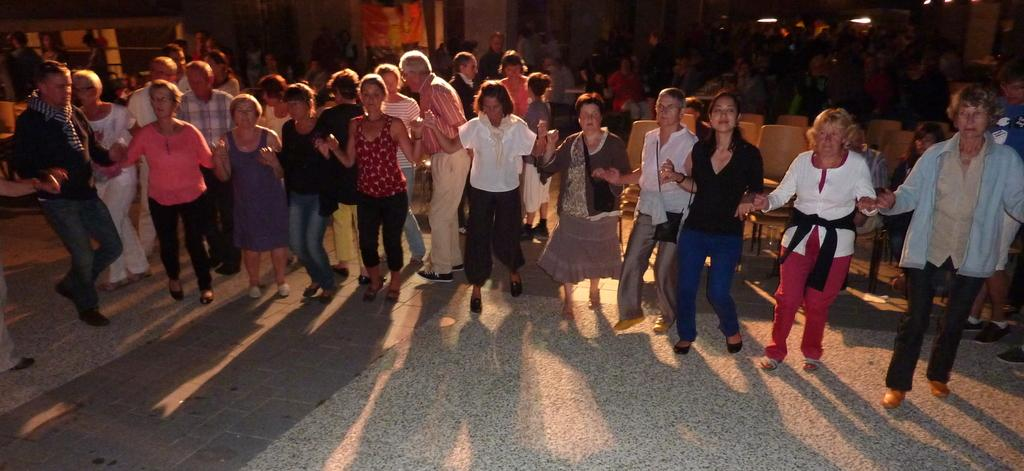Who or what can be seen in the image? There are people in the image. What is the surface beneath the people in the image? The ground is visible in the image. What type of furniture is present in the image? There are chairs in the image. What is attached to the wall in the image? There is an object on the wall in the image. What is the people in the image learning about? The image does not provide information about what the people are learning. 